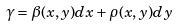<formula> <loc_0><loc_0><loc_500><loc_500>\gamma = \beta ( x , y ) d x + \rho ( x , y ) d y</formula> 